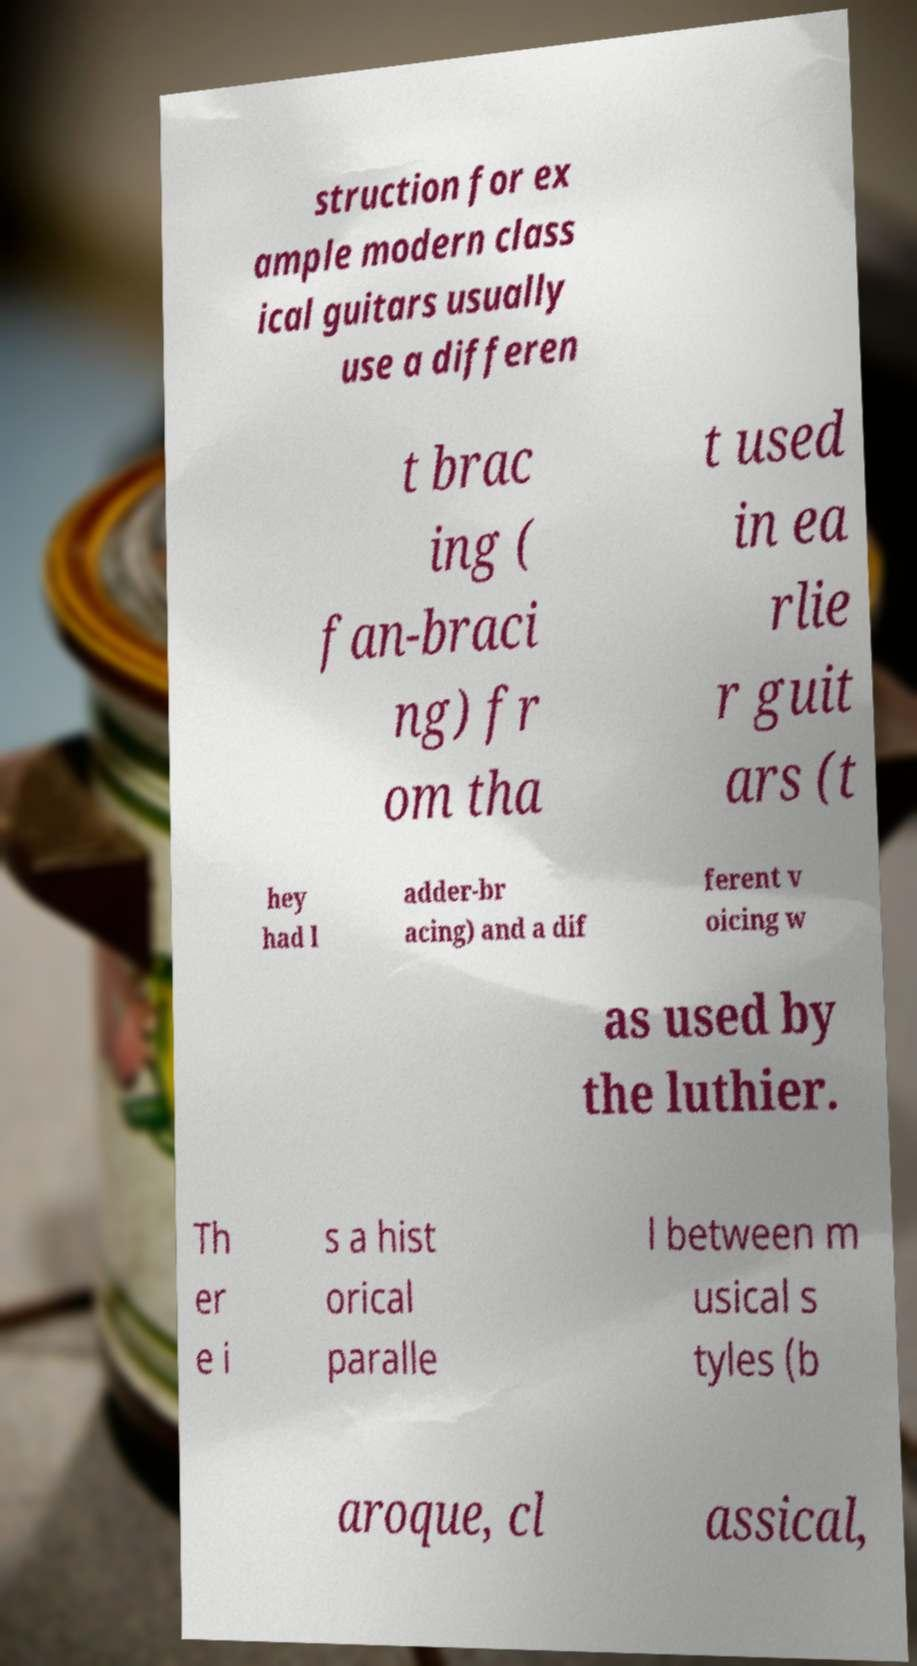Please read and relay the text visible in this image. What does it say? struction for ex ample modern class ical guitars usually use a differen t brac ing ( fan-braci ng) fr om tha t used in ea rlie r guit ars (t hey had l adder-br acing) and a dif ferent v oicing w as used by the luthier. Th er e i s a hist orical paralle l between m usical s tyles (b aroque, cl assical, 